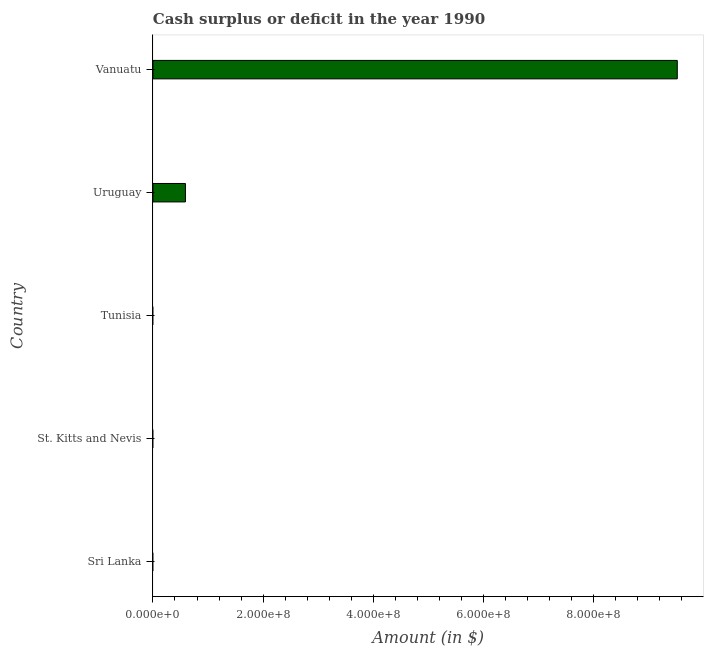Does the graph contain any zero values?
Provide a succinct answer. Yes. Does the graph contain grids?
Your response must be concise. No. What is the title of the graph?
Your answer should be compact. Cash surplus or deficit in the year 1990. What is the label or title of the X-axis?
Keep it short and to the point. Amount (in $). What is the cash surplus or deficit in St. Kitts and Nevis?
Provide a succinct answer. 0. Across all countries, what is the maximum cash surplus or deficit?
Your answer should be compact. 9.52e+08. Across all countries, what is the minimum cash surplus or deficit?
Make the answer very short. 0. In which country was the cash surplus or deficit maximum?
Provide a succinct answer. Vanuatu. What is the sum of the cash surplus or deficit?
Keep it short and to the point. 1.01e+09. What is the average cash surplus or deficit per country?
Keep it short and to the point. 2.02e+08. What is the median cash surplus or deficit?
Ensure brevity in your answer.  0. What is the ratio of the cash surplus or deficit in Uruguay to that in Vanuatu?
Your response must be concise. 0.06. Is the difference between the cash surplus or deficit in Uruguay and Vanuatu greater than the difference between any two countries?
Ensure brevity in your answer.  No. What is the difference between the highest and the lowest cash surplus or deficit?
Ensure brevity in your answer.  9.52e+08. In how many countries, is the cash surplus or deficit greater than the average cash surplus or deficit taken over all countries?
Give a very brief answer. 1. How many bars are there?
Make the answer very short. 2. Are all the bars in the graph horizontal?
Offer a terse response. Yes. How many countries are there in the graph?
Offer a very short reply. 5. What is the Amount (in $) in Uruguay?
Offer a very short reply. 5.90e+07. What is the Amount (in $) in Vanuatu?
Your response must be concise. 9.52e+08. What is the difference between the Amount (in $) in Uruguay and Vanuatu?
Your answer should be very brief. -8.93e+08. What is the ratio of the Amount (in $) in Uruguay to that in Vanuatu?
Offer a very short reply. 0.06. 